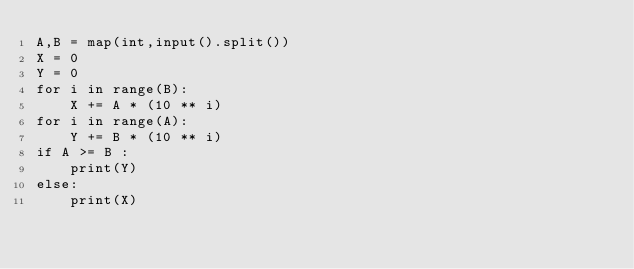<code> <loc_0><loc_0><loc_500><loc_500><_Python_>A,B = map(int,input().split())
X = 0
Y = 0
for i in range(B):
    X += A * (10 ** i)
for i in range(A):
    Y += B * (10 ** i)
if A >= B :
    print(Y)
else:
    print(X)
</code> 